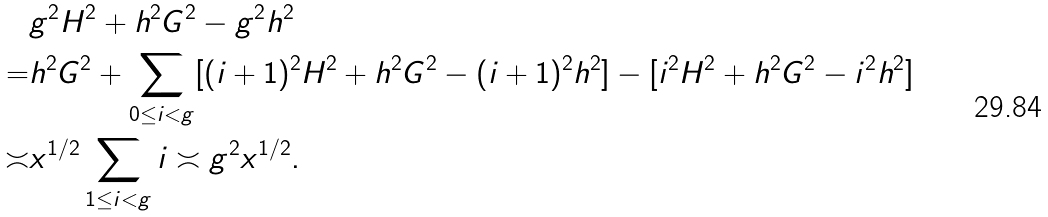Convert formula to latex. <formula><loc_0><loc_0><loc_500><loc_500>& g ^ { 2 } H ^ { 2 } + h ^ { 2 } G ^ { 2 } - g ^ { 2 } h ^ { 2 } \\ = & h ^ { 2 } G ^ { 2 } + \sum _ { 0 \leq i < g } [ ( i + 1 ) ^ { 2 } H ^ { 2 } + h ^ { 2 } G ^ { 2 } - ( i + 1 ) ^ { 2 } h ^ { 2 } ] - [ i ^ { 2 } H ^ { 2 } + h ^ { 2 } G ^ { 2 } - i ^ { 2 } h ^ { 2 } ] \\ \asymp & x ^ { 1 / 2 } \sum _ { 1 \leq i < g } i \asymp g ^ { 2 } x ^ { 1 / 2 } .</formula> 